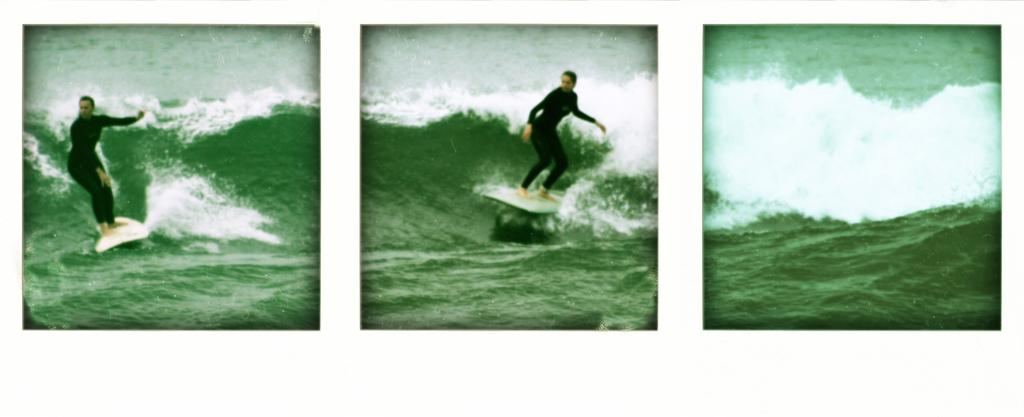What is the main theme of the collage? The main theme of the collage is water with waves. How many images of water with waves are in the collage? There are three images of water with waves in the collage. What activity is the person performing in two of the images? The person is surfing on the water in two of the images. What tool is the person using to surf? The person is using a surfboard to surf. What type of jelly can be seen floating in the water in the image? There is no jelly present in the image; it features water with waves and a person surfing. What event is taking place in the image? The image does not depict a specific event; it simply shows water with waves and a person surfing. 